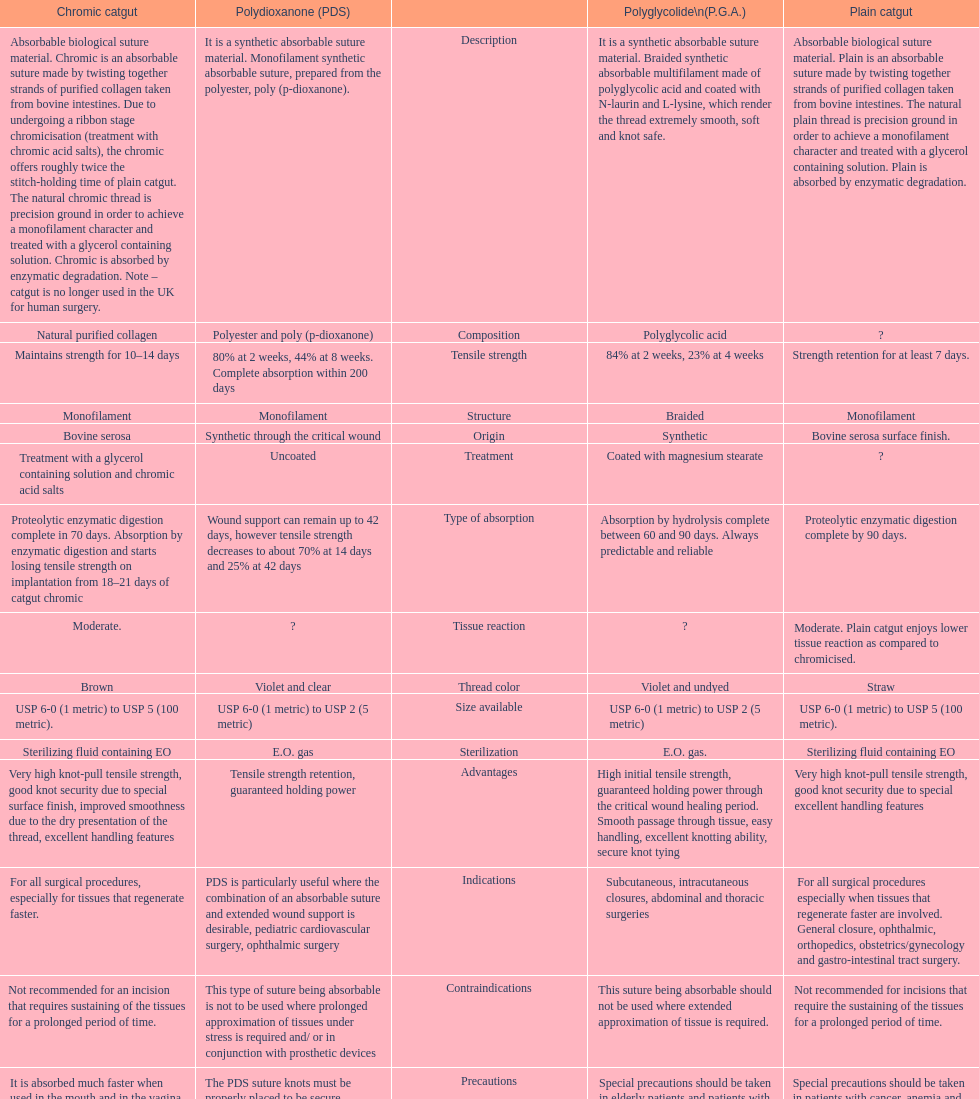What is the total number of suture materials that have a mono-filament structure? 3. 